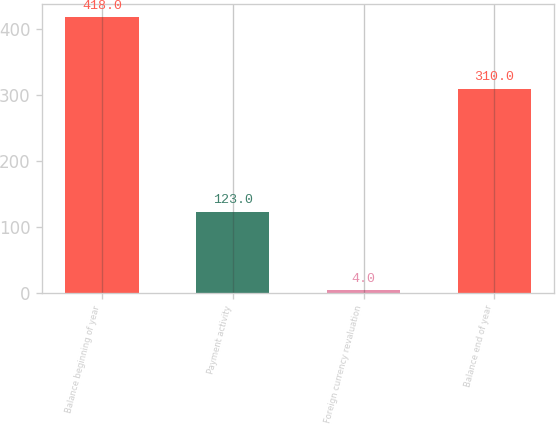Convert chart to OTSL. <chart><loc_0><loc_0><loc_500><loc_500><bar_chart><fcel>Balance beginning of year<fcel>Payment activity<fcel>Foreign currency revaluation<fcel>Balance end of year<nl><fcel>418<fcel>123<fcel>4<fcel>310<nl></chart> 